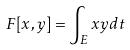Convert formula to latex. <formula><loc_0><loc_0><loc_500><loc_500>F [ x , y ] = \int _ { E } x y d t</formula> 